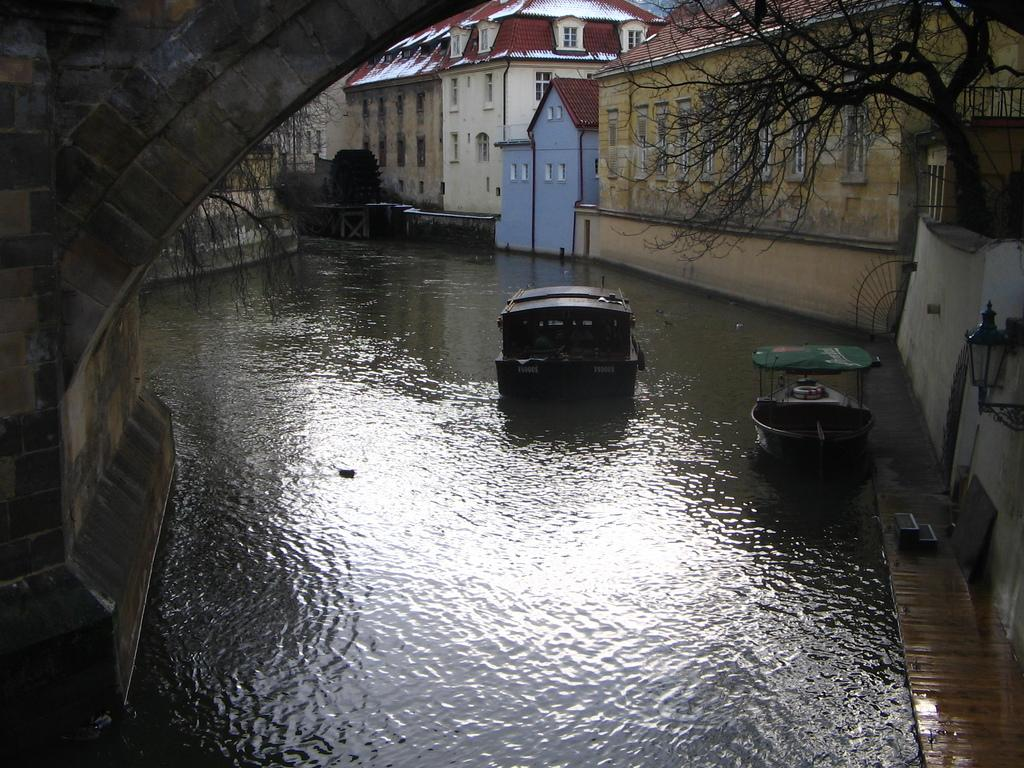What is the primary element in the image? There is there any water visible? What is floating on the surface of the water? There are boats on the surface of the water. What structure can be seen in the image? There is a bridge in the image. What type of vegetation is present in the image? There is a tree in the image. What type of lighting is present in the image? There is a lamp in the image. What type of man-made structures are visible in the image? There are buildings in the image. What architectural feature can be seen on the buildings? There are windows visible on the buildings. Can you see an airplane flying over the water in the image? No, there is no airplane visible in the image. Is there a donkey observing the boats from the bridge in the image? No, there is no donkey present in the image. 